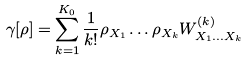<formula> <loc_0><loc_0><loc_500><loc_500>\gamma [ \rho ] = \sum _ { k = 1 } ^ { K _ { 0 } } \frac { 1 } { k ! } \rho _ { X _ { 1 } } \dots \rho _ { X _ { k } } W ^ { ( k ) } _ { X _ { 1 } \dots X _ { k } }</formula> 